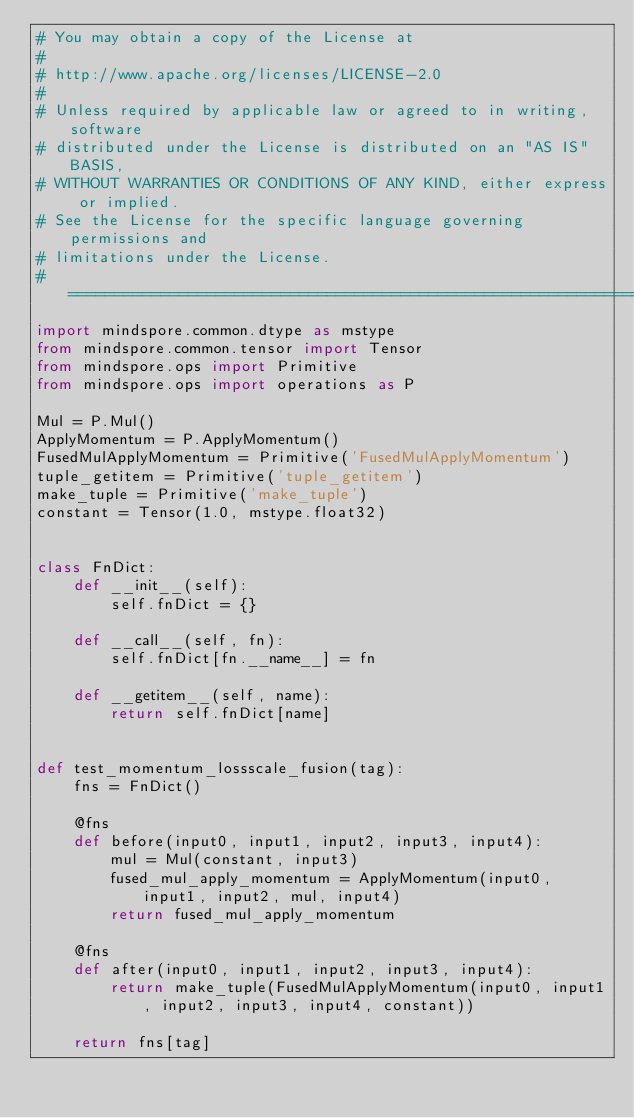Convert code to text. <code><loc_0><loc_0><loc_500><loc_500><_Python_># You may obtain a copy of the License at
#
# http://www.apache.org/licenses/LICENSE-2.0
#
# Unless required by applicable law or agreed to in writing, software
# distributed under the License is distributed on an "AS IS" BASIS,
# WITHOUT WARRANTIES OR CONDITIONS OF ANY KIND, either express or implied.
# See the License for the specific language governing permissions and
# limitations under the License.
# ============================================================================
import mindspore.common.dtype as mstype
from mindspore.common.tensor import Tensor
from mindspore.ops import Primitive
from mindspore.ops import operations as P

Mul = P.Mul()
ApplyMomentum = P.ApplyMomentum()
FusedMulApplyMomentum = Primitive('FusedMulApplyMomentum')
tuple_getitem = Primitive('tuple_getitem')
make_tuple = Primitive('make_tuple')
constant = Tensor(1.0, mstype.float32)


class FnDict:
    def __init__(self):
        self.fnDict = {}

    def __call__(self, fn):
        self.fnDict[fn.__name__] = fn

    def __getitem__(self, name):
        return self.fnDict[name]


def test_momentum_lossscale_fusion(tag):
    fns = FnDict()

    @fns
    def before(input0, input1, input2, input3, input4):
        mul = Mul(constant, input3)
        fused_mul_apply_momentum = ApplyMomentum(input0, input1, input2, mul, input4)
        return fused_mul_apply_momentum

    @fns
    def after(input0, input1, input2, input3, input4):
        return make_tuple(FusedMulApplyMomentum(input0, input1, input2, input3, input4, constant))

    return fns[tag]
</code> 